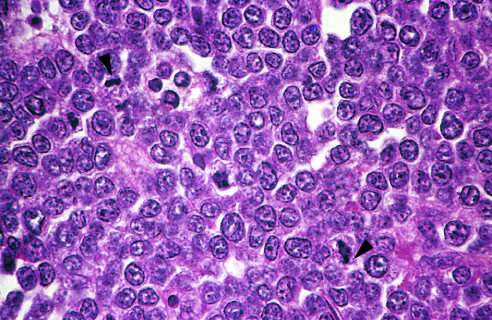re the principal cellular alterations that characterize reversible cell injury and necrosis fairly uniform, giving a monotonous appearance?
Answer the question using a single word or phrase. No 